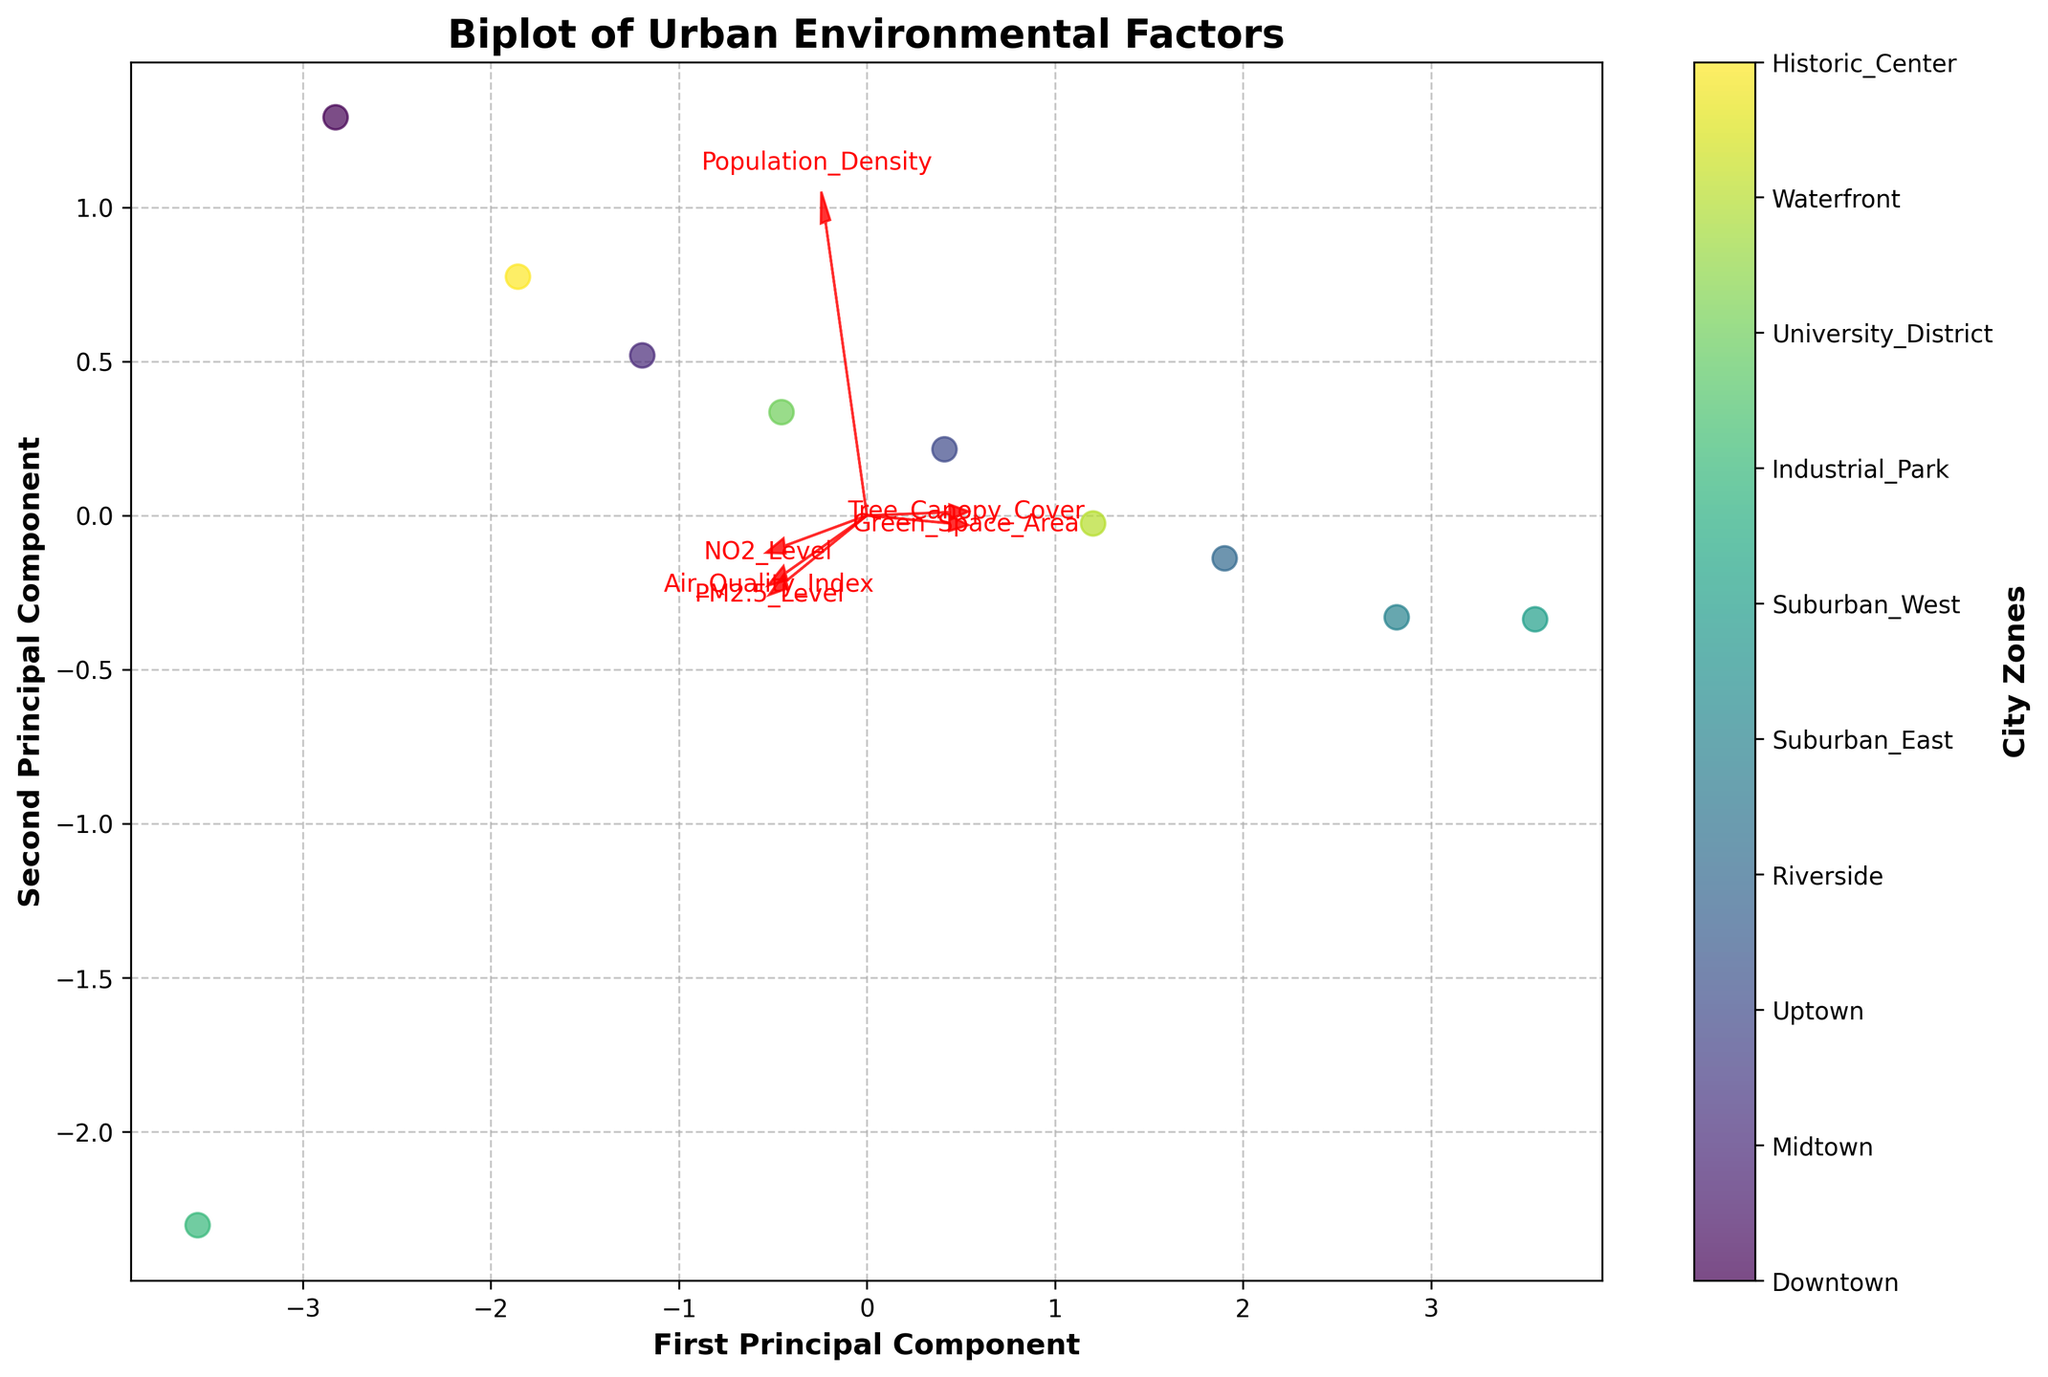How many city zones are shown in the biplot? By counting the data points in the scatter plot, we can determine that there are 10 city zones represented. The colorbar also confirms there are 10 distinct labels corresponding to the city zones.
Answer: 10 Which feature vector seems to have the largest impact on the first principal component? By examining the lengths and directions of the arrows, "Green_Space_Area" appears to have the most significant projection onto the first principal component axis, indicating its large impact.
Answer: Green_Space_Area Are the zones with higher green space area generally associated with better air quality indices? In the biplot, zones with higher "Green_Space_Area" typically align with better "Air_Quality_Index" (lower values). This suggests a correlation where higher green space is linked with cleaner air.
Answer: Yes Which zone is likely furthest from the origin on the second principal component? By observing the scatter plot, the zone located furthest vertically (in the positive or negative direction) from the origin represents the second principal component. "Industrial_Park" seems to be the furthest.
Answer: Industrial_Park What is the relationship between "Tree_Canopy_Cover" and "NO2_Level"? The arrows for "Tree_Canopy_Cover" and "NO2_Level" point in nearly opposite directions, indicating a negative correlation between the two features.
Answer: Negative correlation Is "Population_Density" more correlated to "PM2.5_Level" or "NO2_Level"? By looking at the direction of the feature arrows, "Population_Density" has a closer alignment with the "NO2_Level" arrow, indicating a stronger correlation between these two features.
Answer: NO2_Level Which two zones are likely to have the most similar environmental profiles? Zones positioned close to each other in the scatter plot suggest similar environmental profiles. "Riverside" and "Waterfront" appear to be positioned near each other, suggesting similarity.
Answer: Riverside and Waterfront Which feature vector points in a similar direction as the "Air_Quality_Index"? The "PM2.5_Level" vector points in a similar direction as "Air_Quality_Index," indicating they are positively correlated.
Answer: PM2.5_Level How does "Suburban_West" compare to "Downtown" in terms of green space area and NO2 levels? In the biplot, "Suburban_West" is associated with higher "Green_Space_Area" and lower "NO2_Level" compared to "Downtown."
Answer: More green space and lower NO2 levels If we want to improve tree canopy cover, which zones should we prioritize from the least to most in need of improvements? We should look at the zones with the least projection in the direction of "Tree_Canopy_Cover." "Industrial_Park," "Downtown," and "Historic_Center" appear to have the smallest values.
Answer: Industrial_Park, Downtown, Historic_Center 